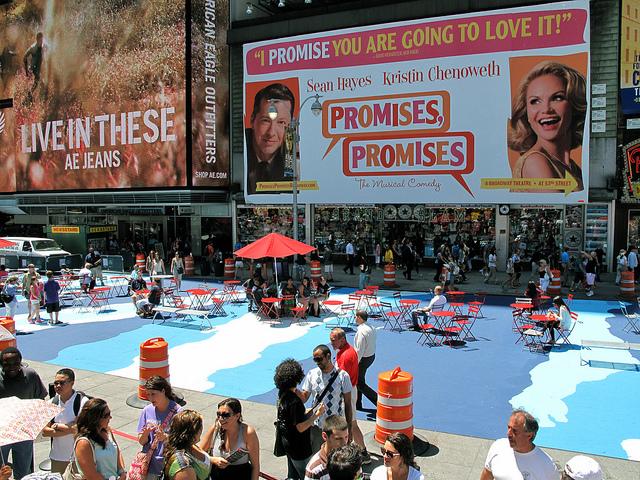What color is the umbrella?
Answer briefly. Red. Who stars in the movie advertised?
Short answer required. Sean hayes and kristin chenoweth. Is the movie a comedy or drama?
Answer briefly. Comedy. 